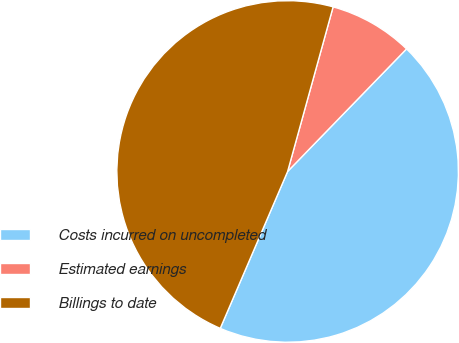Convert chart. <chart><loc_0><loc_0><loc_500><loc_500><pie_chart><fcel>Costs incurred on uncompleted<fcel>Estimated earnings<fcel>Billings to date<nl><fcel>44.2%<fcel>7.97%<fcel>47.84%<nl></chart> 